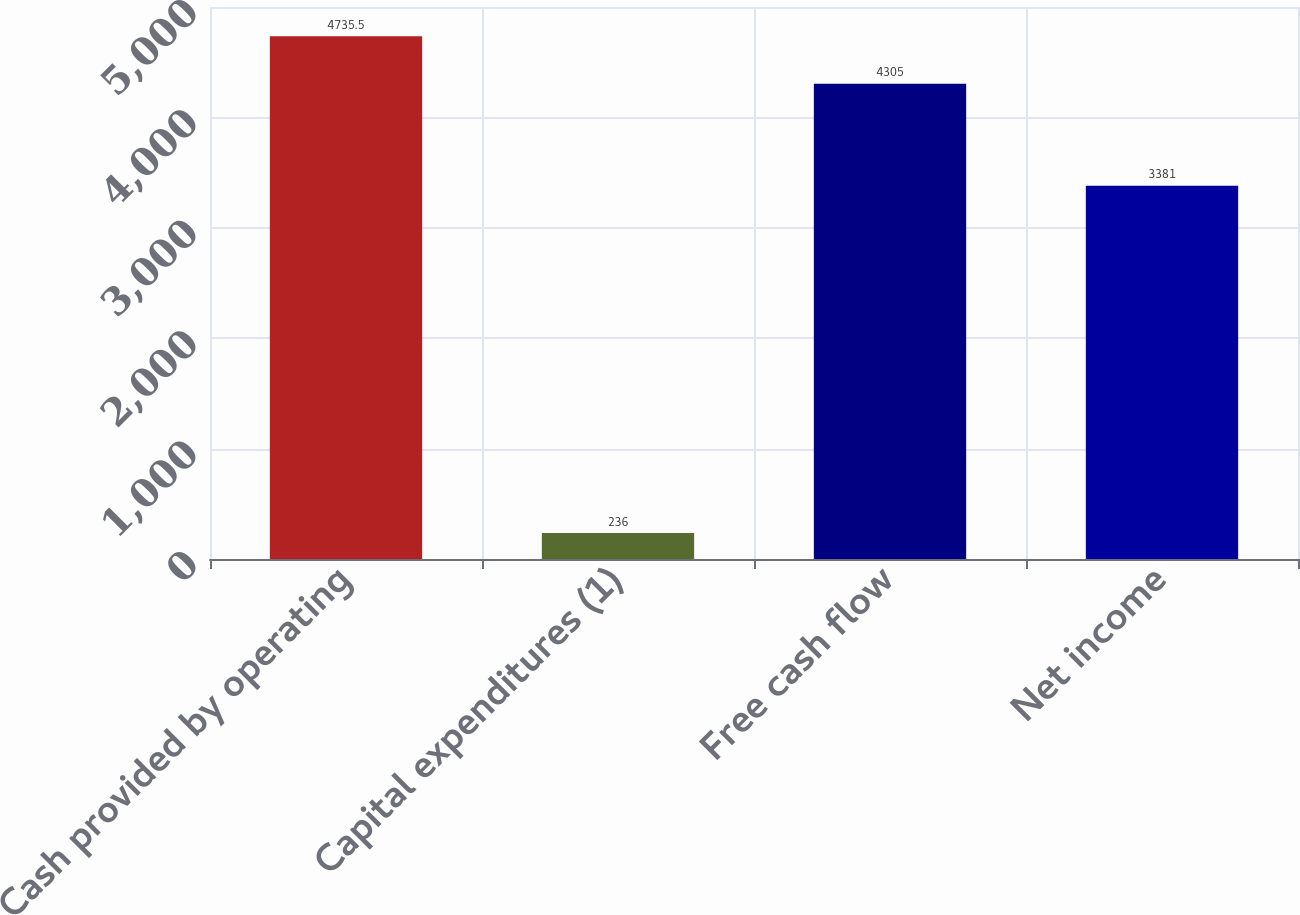Convert chart to OTSL. <chart><loc_0><loc_0><loc_500><loc_500><bar_chart><fcel>Cash provided by operating<fcel>Capital expenditures (1)<fcel>Free cash flow<fcel>Net income<nl><fcel>4735.5<fcel>236<fcel>4305<fcel>3381<nl></chart> 